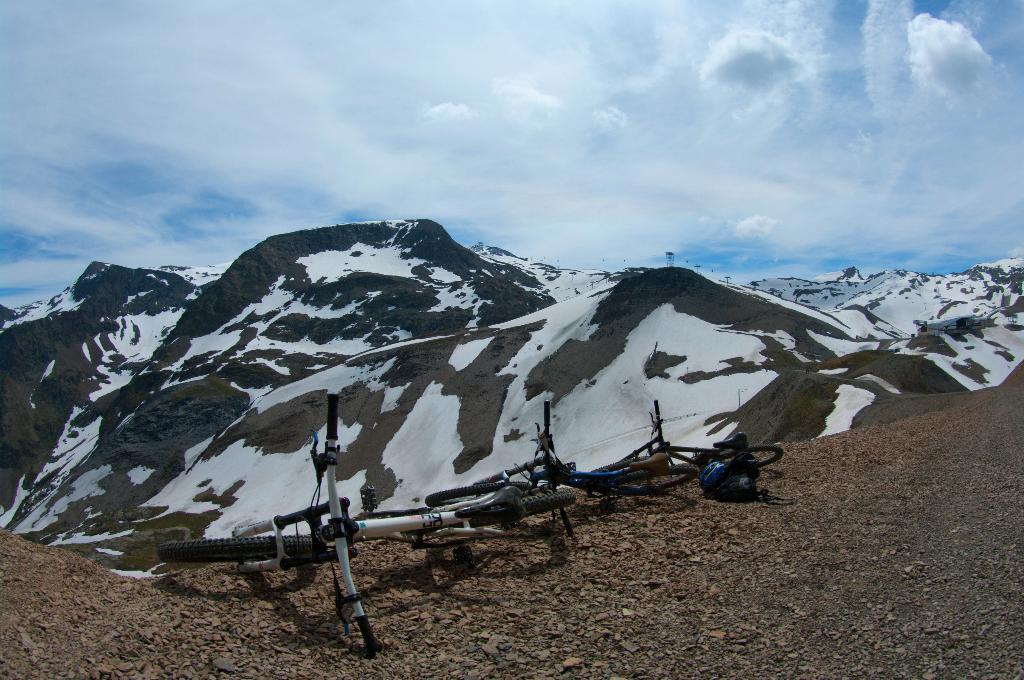What type of vehicles are in the image? There are bicycles in the image. What can be seen in the background of the image? There are hills and clouds visible in the background of the image. What type of record can be seen on the bicycle in the image? There is no record present on the bicycle or in the image. Is there a scarecrow positioned near the hills in the image? There is no scarecrow present in the image. 